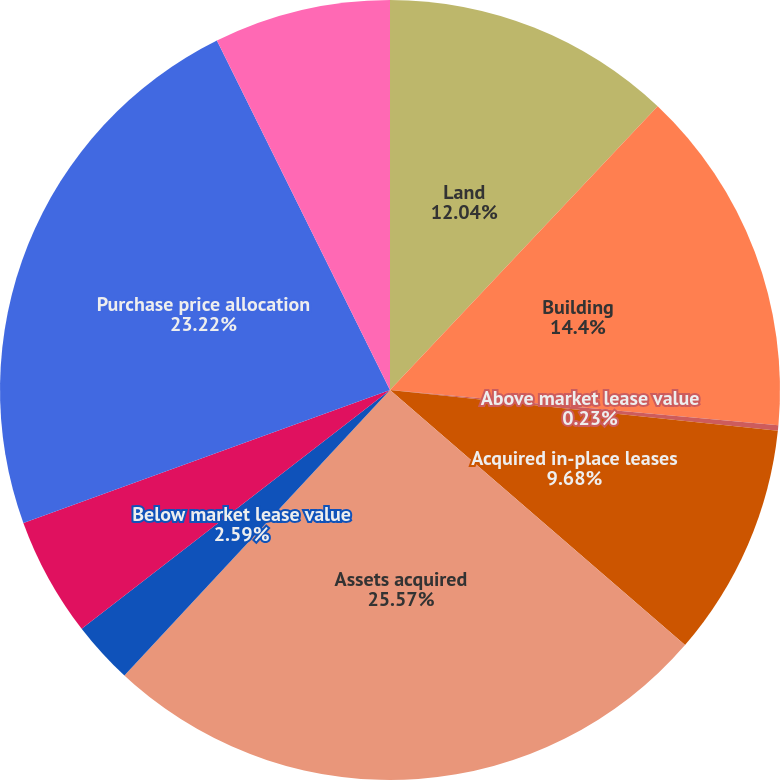<chart> <loc_0><loc_0><loc_500><loc_500><pie_chart><fcel>Land<fcel>Building<fcel>Above market lease value<fcel>Acquired in-place leases<fcel>Assets acquired<fcel>Below market lease value<fcel>Liabilities assumed<fcel>Purchase price allocation<fcel>Net consideration funded by us<nl><fcel>12.04%<fcel>14.4%<fcel>0.23%<fcel>9.68%<fcel>25.58%<fcel>2.59%<fcel>4.95%<fcel>23.22%<fcel>7.32%<nl></chart> 